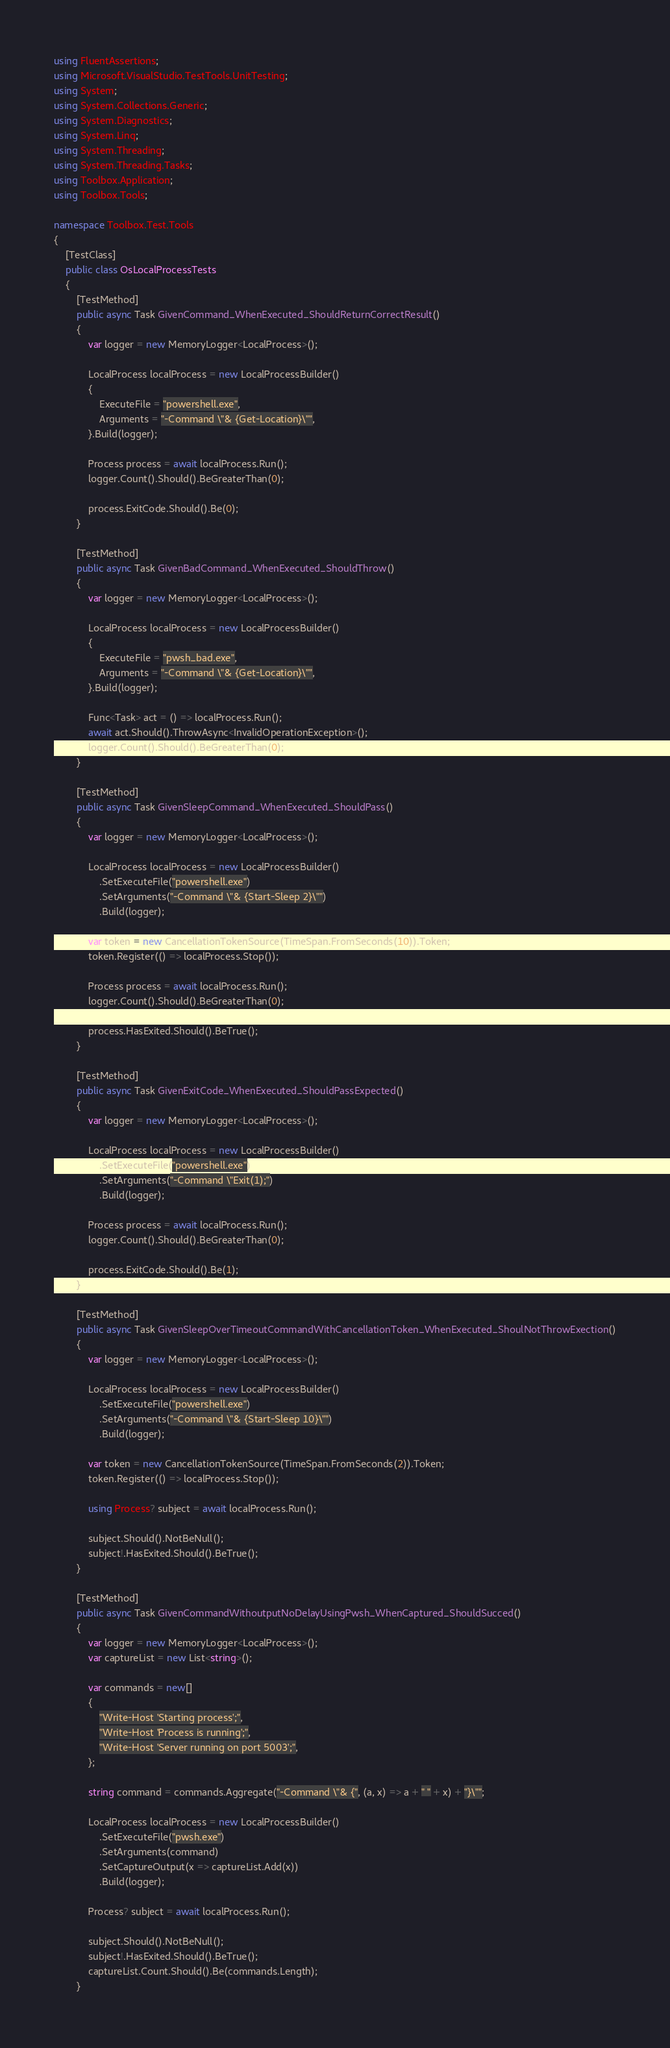<code> <loc_0><loc_0><loc_500><loc_500><_C#_>using FluentAssertions;
using Microsoft.VisualStudio.TestTools.UnitTesting;
using System;
using System.Collections.Generic;
using System.Diagnostics;
using System.Linq;
using System.Threading;
using System.Threading.Tasks;
using Toolbox.Application;
using Toolbox.Tools;

namespace Toolbox.Test.Tools
{
    [TestClass]
    public class OsLocalProcessTests
    {
        [TestMethod]
        public async Task GivenCommand_WhenExecuted_ShouldReturnCorrectResult()
        {
            var logger = new MemoryLogger<LocalProcess>();

            LocalProcess localProcess = new LocalProcessBuilder()
            {
                ExecuteFile = "powershell.exe",
                Arguments = "-Command \"& {Get-Location}\"",
            }.Build(logger);

            Process process = await localProcess.Run();
            logger.Count().Should().BeGreaterThan(0);

            process.ExitCode.Should().Be(0);
        }

        [TestMethod]
        public async Task GivenBadCommand_WhenExecuted_ShouldThrow()
        {
            var logger = new MemoryLogger<LocalProcess>();

            LocalProcess localProcess = new LocalProcessBuilder()
            {
                ExecuteFile = "pwsh_bad.exe",
                Arguments = "-Command \"& {Get-Location}\"",
            }.Build(logger);

            Func<Task> act = () => localProcess.Run();
            await act.Should().ThrowAsync<InvalidOperationException>();
            logger.Count().Should().BeGreaterThan(0);
        }

        [TestMethod]
        public async Task GivenSleepCommand_WhenExecuted_ShouldPass()
        {
            var logger = new MemoryLogger<LocalProcess>();

            LocalProcess localProcess = new LocalProcessBuilder()
                .SetExecuteFile("powershell.exe")
                .SetArguments("-Command \"& {Start-Sleep 2}\"")
                .Build(logger);

            var token = new CancellationTokenSource(TimeSpan.FromSeconds(10)).Token;
            token.Register(() => localProcess.Stop());

            Process process = await localProcess.Run();
            logger.Count().Should().BeGreaterThan(0);

            process.HasExited.Should().BeTrue();
        }

        [TestMethod]
        public async Task GivenExitCode_WhenExecuted_ShouldPassExpected()
        {
            var logger = new MemoryLogger<LocalProcess>();

            LocalProcess localProcess = new LocalProcessBuilder()
                .SetExecuteFile("powershell.exe")
                .SetArguments("-Command \"Exit(1);")
                .Build(logger);

            Process process = await localProcess.Run();
            logger.Count().Should().BeGreaterThan(0);

            process.ExitCode.Should().Be(1);
        }

        [TestMethod]
        public async Task GivenSleepOverTimeoutCommandWithCancellationToken_WhenExecuted_ShoulNotThrowExection()
        {
            var logger = new MemoryLogger<LocalProcess>();

            LocalProcess localProcess = new LocalProcessBuilder()
                .SetExecuteFile("powershell.exe")
                .SetArguments("-Command \"& {Start-Sleep 10}\"")
                .Build(logger);

            var token = new CancellationTokenSource(TimeSpan.FromSeconds(2)).Token;
            token.Register(() => localProcess.Stop());

            using Process? subject = await localProcess.Run();

            subject.Should().NotBeNull();
            subject!.HasExited.Should().BeTrue();
        }

        [TestMethod]
        public async Task GivenCommandWithoutputNoDelayUsingPwsh_WhenCaptured_ShouldSucced()
        {
            var logger = new MemoryLogger<LocalProcess>();
            var captureList = new List<string>();

            var commands = new[]
            {
                "Write-Host 'Starting process';",
                "Write-Host 'Process is running';",
                "Write-Host 'Server running on port 5003';",
            };

            string command = commands.Aggregate("-Command \"& {", (a, x) => a + " " + x) + "}\"";

            LocalProcess localProcess = new LocalProcessBuilder()
                .SetExecuteFile("pwsh.exe")
                .SetArguments(command)
                .SetCaptureOutput(x => captureList.Add(x))
                .Build(logger);

            Process? subject = await localProcess.Run();

            subject.Should().NotBeNull();
            subject!.HasExited.Should().BeTrue();
            captureList.Count.Should().Be(commands.Length);
        }
</code> 